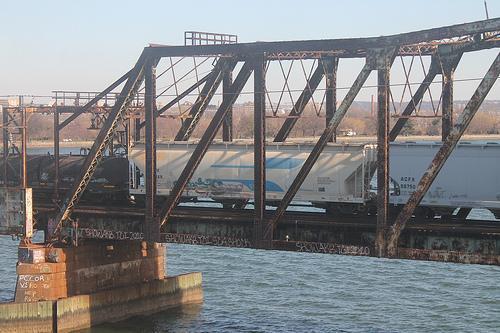How many train cars are in the picture?
Give a very brief answer. 3. 